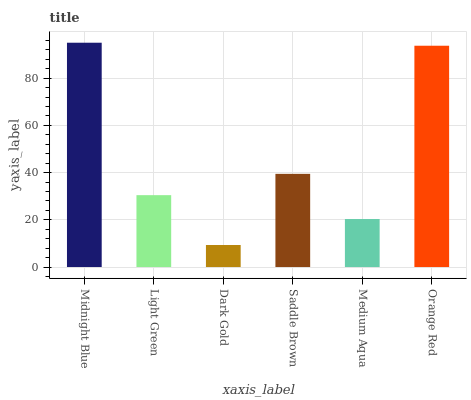Is Dark Gold the minimum?
Answer yes or no. Yes. Is Midnight Blue the maximum?
Answer yes or no. Yes. Is Light Green the minimum?
Answer yes or no. No. Is Light Green the maximum?
Answer yes or no. No. Is Midnight Blue greater than Light Green?
Answer yes or no. Yes. Is Light Green less than Midnight Blue?
Answer yes or no. Yes. Is Light Green greater than Midnight Blue?
Answer yes or no. No. Is Midnight Blue less than Light Green?
Answer yes or no. No. Is Saddle Brown the high median?
Answer yes or no. Yes. Is Light Green the low median?
Answer yes or no. Yes. Is Dark Gold the high median?
Answer yes or no. No. Is Saddle Brown the low median?
Answer yes or no. No. 